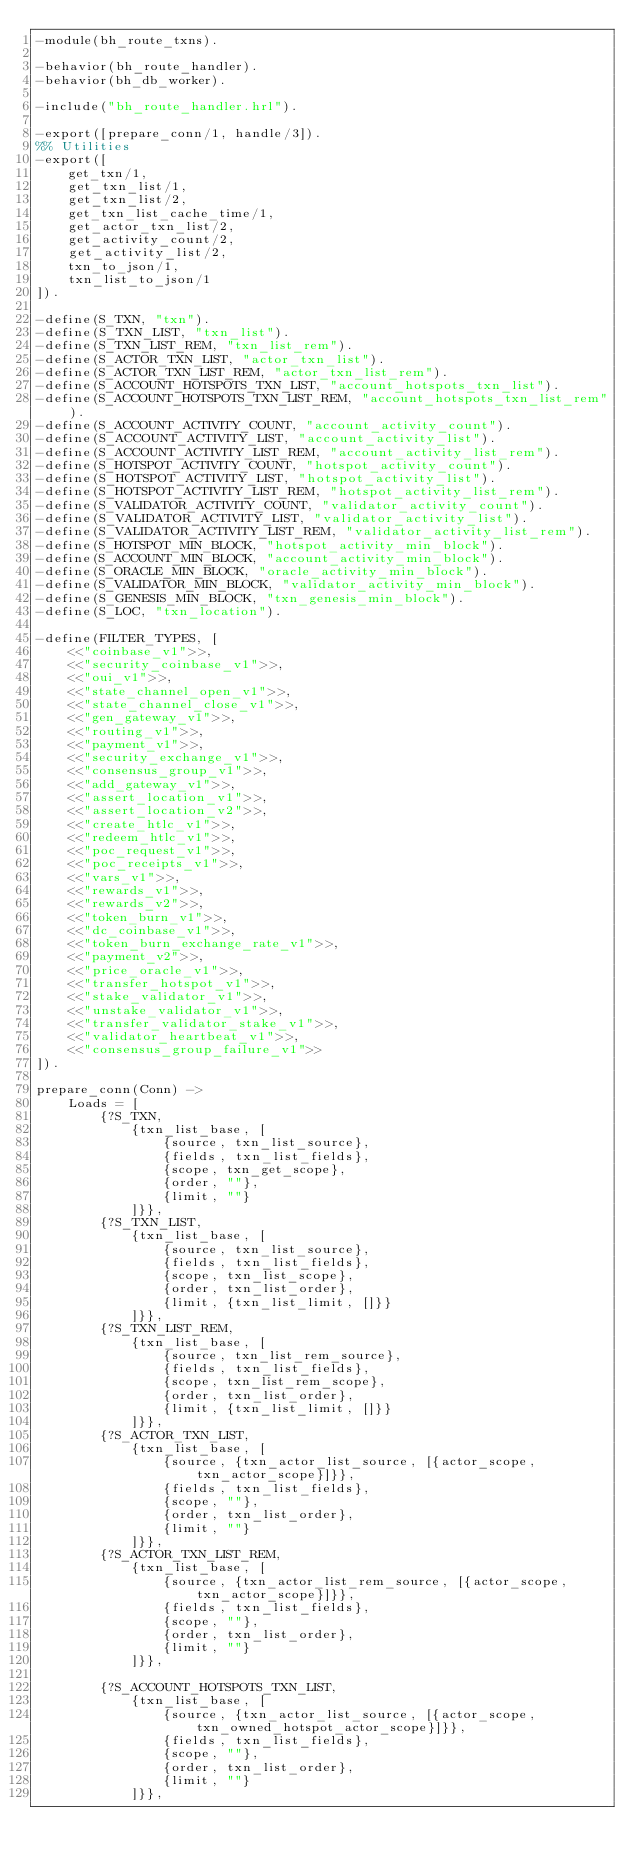<code> <loc_0><loc_0><loc_500><loc_500><_Erlang_>-module(bh_route_txns).

-behavior(bh_route_handler).
-behavior(bh_db_worker).

-include("bh_route_handler.hrl").

-export([prepare_conn/1, handle/3]).
%% Utilities
-export([
    get_txn/1,
    get_txn_list/1,
    get_txn_list/2,
    get_txn_list_cache_time/1,
    get_actor_txn_list/2,
    get_activity_count/2,
    get_activity_list/2,
    txn_to_json/1,
    txn_list_to_json/1
]).

-define(S_TXN, "txn").
-define(S_TXN_LIST, "txn_list").
-define(S_TXN_LIST_REM, "txn_list_rem").
-define(S_ACTOR_TXN_LIST, "actor_txn_list").
-define(S_ACTOR_TXN_LIST_REM, "actor_txn_list_rem").
-define(S_ACCOUNT_HOTSPOTS_TXN_LIST, "account_hotspots_txn_list").
-define(S_ACCOUNT_HOTSPOTS_TXN_LIST_REM, "account_hotspots_txn_list_rem").
-define(S_ACCOUNT_ACTIVITY_COUNT, "account_activity_count").
-define(S_ACCOUNT_ACTIVITY_LIST, "account_activity_list").
-define(S_ACCOUNT_ACTIVITY_LIST_REM, "account_activity_list_rem").
-define(S_HOTSPOT_ACTIVITY_COUNT, "hotspot_activity_count").
-define(S_HOTSPOT_ACTIVITY_LIST, "hotspot_activity_list").
-define(S_HOTSPOT_ACTIVITY_LIST_REM, "hotspot_activity_list_rem").
-define(S_VALIDATOR_ACTIVITY_COUNT, "validator_activity_count").
-define(S_VALIDATOR_ACTIVITY_LIST, "validator_activity_list").
-define(S_VALIDATOR_ACTIVITY_LIST_REM, "validator_activity_list_rem").
-define(S_HOTSPOT_MIN_BLOCK, "hotspot_activity_min_block").
-define(S_ACCOUNT_MIN_BLOCK, "account_activity_min_block").
-define(S_ORACLE_MIN_BLOCK, "oracle_activity_min_block").
-define(S_VALIDATOR_MIN_BLOCK, "validator_activity_min_block").
-define(S_GENESIS_MIN_BLOCK, "txn_genesis_min_block").
-define(S_LOC, "txn_location").

-define(FILTER_TYPES, [
    <<"coinbase_v1">>,
    <<"security_coinbase_v1">>,
    <<"oui_v1">>,
    <<"state_channel_open_v1">>,
    <<"state_channel_close_v1">>,
    <<"gen_gateway_v1">>,
    <<"routing_v1">>,
    <<"payment_v1">>,
    <<"security_exchange_v1">>,
    <<"consensus_group_v1">>,
    <<"add_gateway_v1">>,
    <<"assert_location_v1">>,
    <<"assert_location_v2">>,
    <<"create_htlc_v1">>,
    <<"redeem_htlc_v1">>,
    <<"poc_request_v1">>,
    <<"poc_receipts_v1">>,
    <<"vars_v1">>,
    <<"rewards_v1">>,
    <<"rewards_v2">>,
    <<"token_burn_v1">>,
    <<"dc_coinbase_v1">>,
    <<"token_burn_exchange_rate_v1">>,
    <<"payment_v2">>,
    <<"price_oracle_v1">>,
    <<"transfer_hotspot_v1">>,
    <<"stake_validator_v1">>,
    <<"unstake_validator_v1">>,
    <<"transfer_validator_stake_v1">>,
    <<"validator_heartbeat_v1">>,
    <<"consensus_group_failure_v1">>
]).

prepare_conn(Conn) ->
    Loads = [
        {?S_TXN,
            {txn_list_base, [
                {source, txn_list_source},
                {fields, txn_list_fields},
                {scope, txn_get_scope},
                {order, ""},
                {limit, ""}
            ]}},
        {?S_TXN_LIST,
            {txn_list_base, [
                {source, txn_list_source},
                {fields, txn_list_fields},
                {scope, txn_list_scope},
                {order, txn_list_order},
                {limit, {txn_list_limit, []}}
            ]}},
        {?S_TXN_LIST_REM,
            {txn_list_base, [
                {source, txn_list_rem_source},
                {fields, txn_list_fields},
                {scope, txn_list_rem_scope},
                {order, txn_list_order},
                {limit, {txn_list_limit, []}}
            ]}},
        {?S_ACTOR_TXN_LIST,
            {txn_list_base, [
                {source, {txn_actor_list_source, [{actor_scope, txn_actor_scope}]}},
                {fields, txn_list_fields},
                {scope, ""},
                {order, txn_list_order},
                {limit, ""}
            ]}},
        {?S_ACTOR_TXN_LIST_REM,
            {txn_list_base, [
                {source, {txn_actor_list_rem_source, [{actor_scope, txn_actor_scope}]}},
                {fields, txn_list_fields},
                {scope, ""},
                {order, txn_list_order},
                {limit, ""}
            ]}},

        {?S_ACCOUNT_HOTSPOTS_TXN_LIST,
            {txn_list_base, [
                {source, {txn_actor_list_source, [{actor_scope, txn_owned_hotspot_actor_scope}]}},
                {fields, txn_list_fields},
                {scope, ""},
                {order, txn_list_order},
                {limit, ""}
            ]}},</code> 